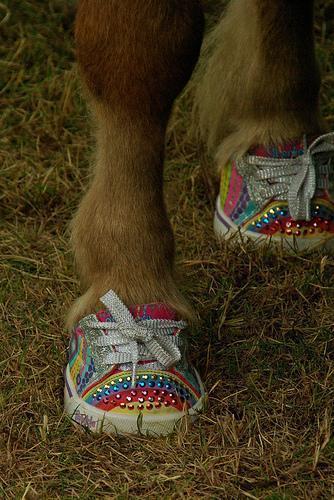How many shoes are pictured?
Give a very brief answer. 2. 